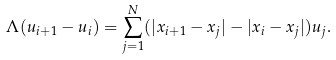<formula> <loc_0><loc_0><loc_500><loc_500>\Lambda ( u _ { i + 1 } - u _ { i } ) = \sum _ { j = 1 } ^ { N } ( | x _ { i + 1 } - x _ { j } | - | x _ { i } - x _ { j } | ) u _ { j } .</formula> 